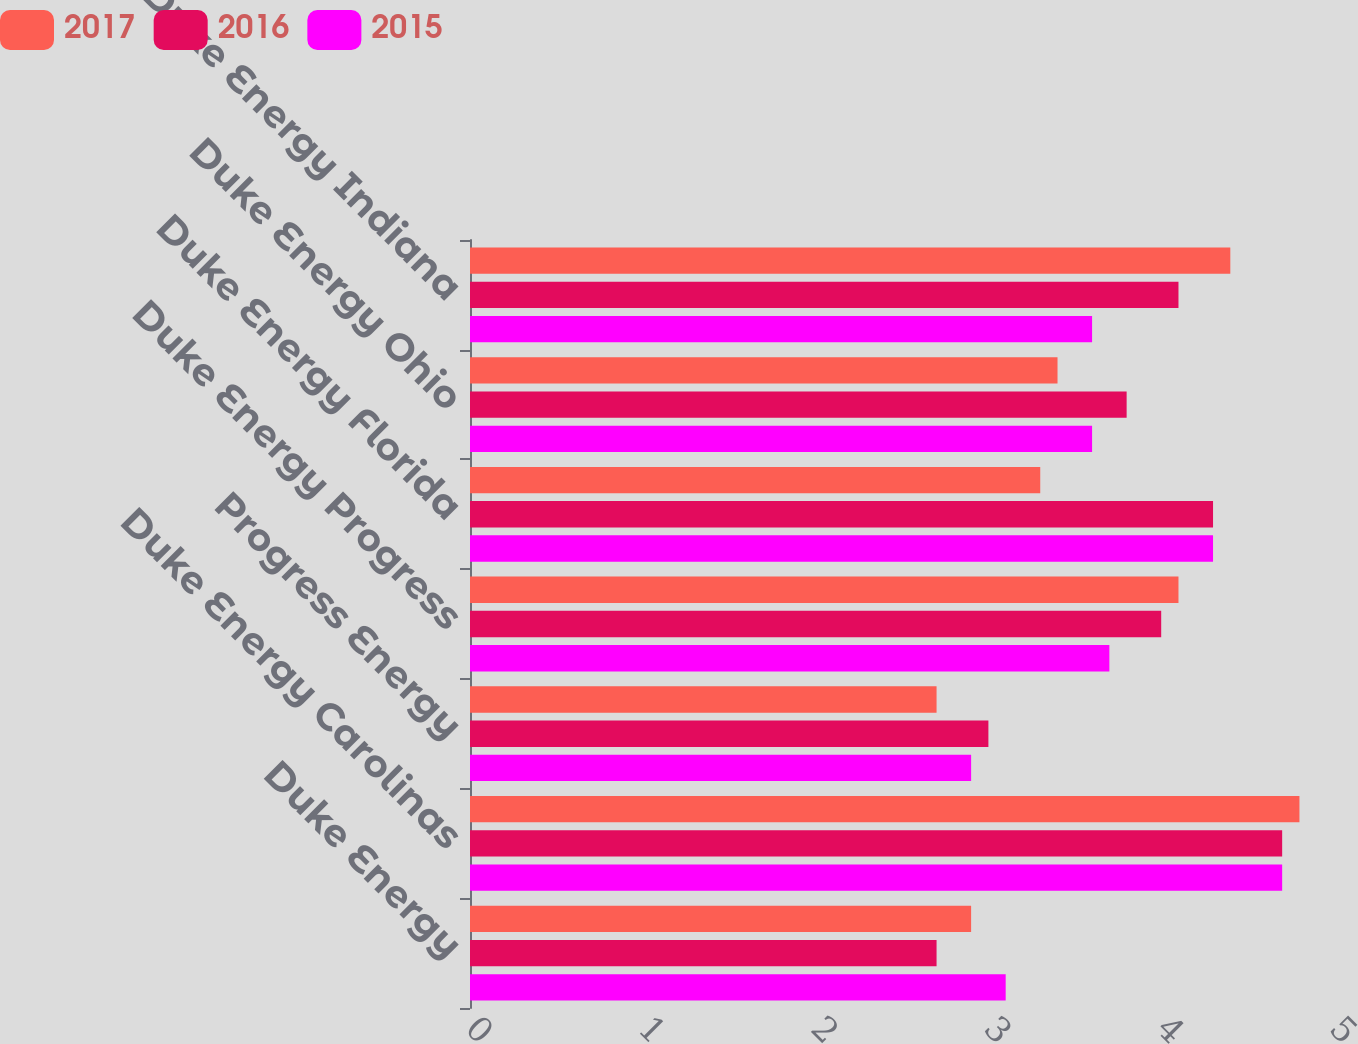Convert chart. <chart><loc_0><loc_0><loc_500><loc_500><stacked_bar_chart><ecel><fcel>Duke Energy<fcel>Duke Energy Carolinas<fcel>Progress Energy<fcel>Duke Energy Progress<fcel>Duke Energy Florida<fcel>Duke Energy Ohio<fcel>Duke Energy Indiana<nl><fcel>2017<fcel>2.9<fcel>4.8<fcel>2.7<fcel>4.1<fcel>3.3<fcel>3.4<fcel>4.4<nl><fcel>2016<fcel>2.7<fcel>4.7<fcel>3<fcel>4<fcel>4.3<fcel>3.8<fcel>4.1<nl><fcel>2015<fcel>3.1<fcel>4.7<fcel>2.9<fcel>3.7<fcel>4.3<fcel>3.6<fcel>3.6<nl></chart> 